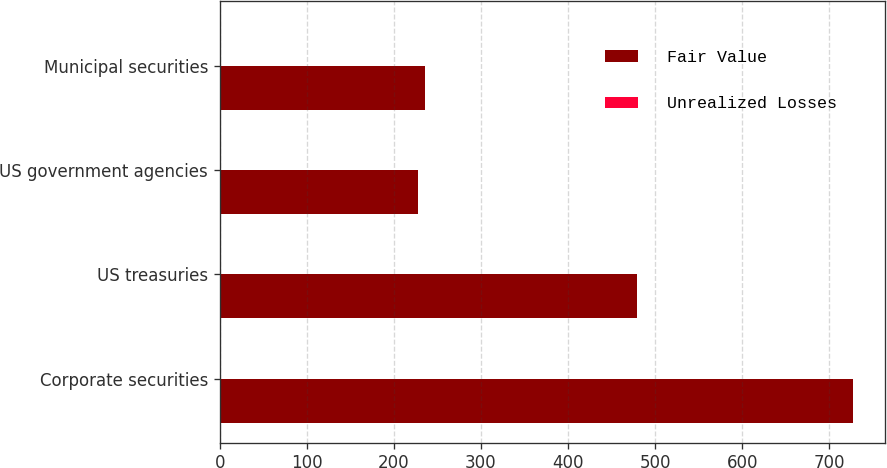Convert chart to OTSL. <chart><loc_0><loc_0><loc_500><loc_500><stacked_bar_chart><ecel><fcel>Corporate securities<fcel>US treasuries<fcel>US government agencies<fcel>Municipal securities<nl><fcel>Fair Value<fcel>727.4<fcel>478.7<fcel>228<fcel>236.3<nl><fcel>Unrealized Losses<fcel>1.7<fcel>0.9<fcel>0.2<fcel>1.3<nl></chart> 